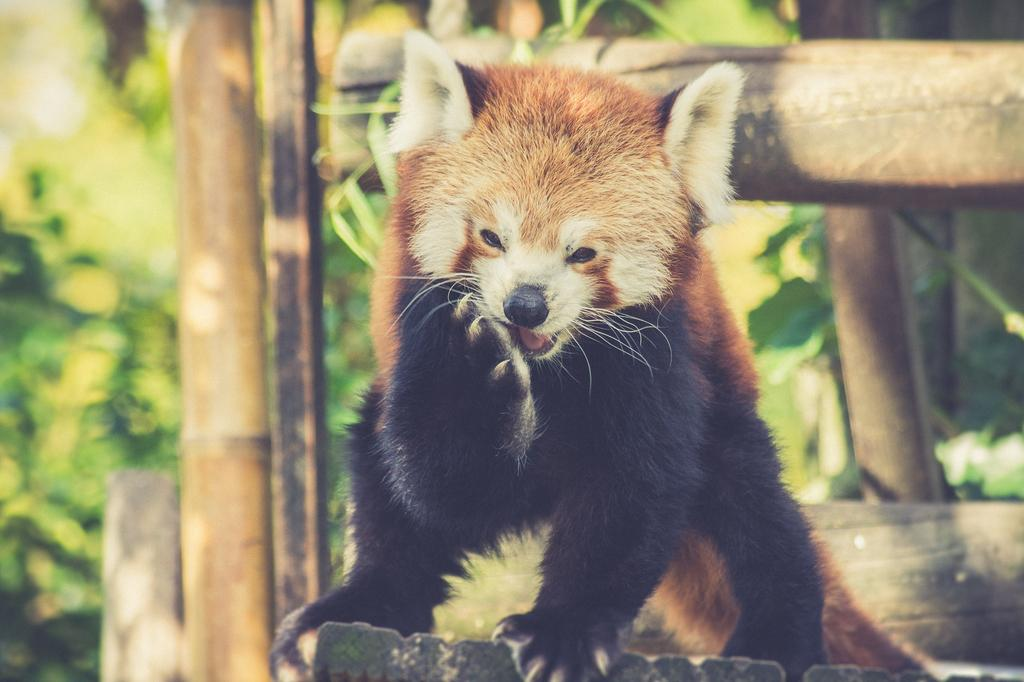What type of animal is in the image? The type of animal cannot be determined from the provided facts. What can be seen in the background of the image? There are trunks and plants in the background of the image. What type of doctor is treating the animal in the image? There is no doctor present in the image, and the type of animal cannot be determined. What belief system is represented by the animal in the image? There is no indication of any belief system in the image, and the type of animal cannot be determined. 